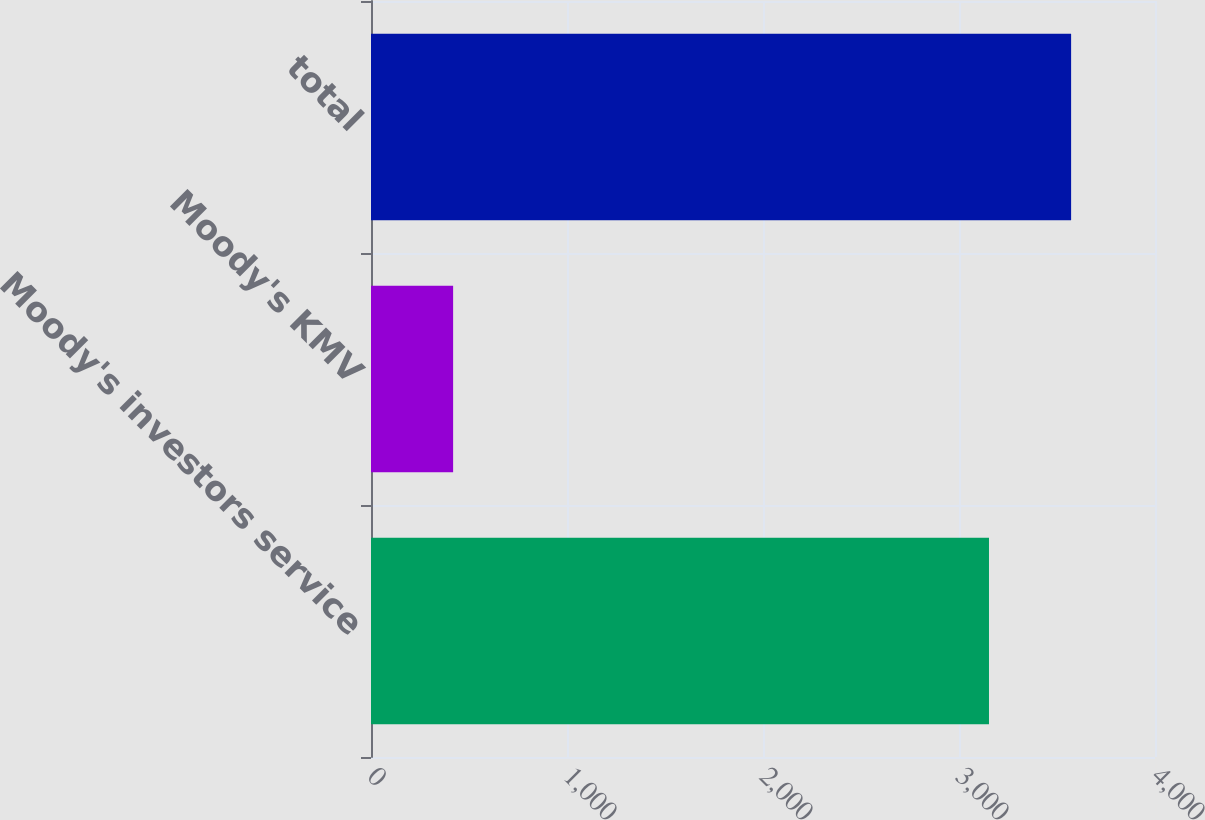<chart> <loc_0><loc_0><loc_500><loc_500><bar_chart><fcel>Moody's investors service<fcel>Moody's KMV<fcel>total<nl><fcel>3153<fcel>419<fcel>3572<nl></chart> 